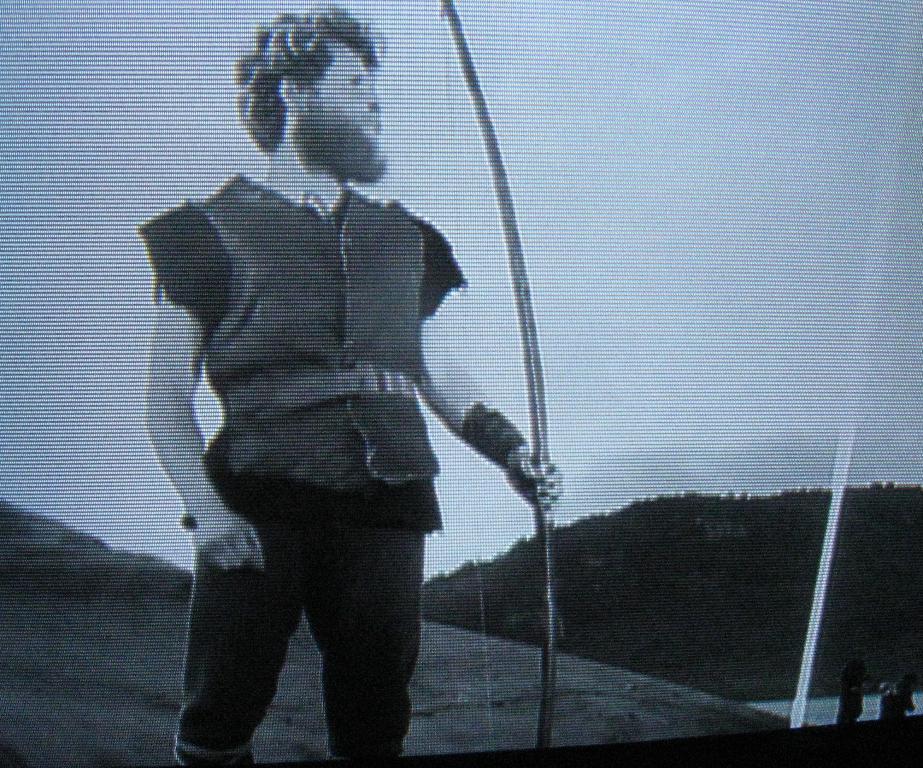Please provide a concise description of this image. This is a black and white image in this image a person holding a bow in his hand, in the background there is a mountain and a sky. 